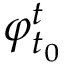<formula> <loc_0><loc_0><loc_500><loc_500>\varphi _ { t _ { 0 } } ^ { t }</formula> 